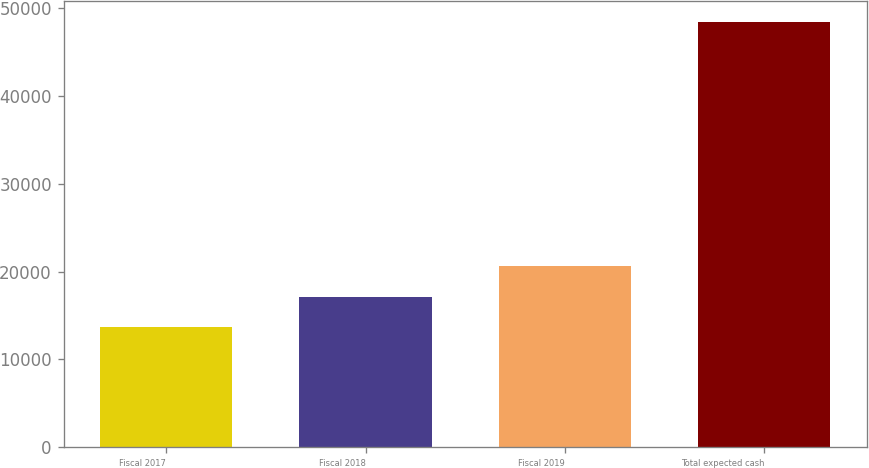<chart> <loc_0><loc_0><loc_500><loc_500><bar_chart><fcel>Fiscal 2017<fcel>Fiscal 2018<fcel>Fiscal 2019<fcel>Total expected cash<nl><fcel>13679<fcel>17155.9<fcel>20632.8<fcel>48448<nl></chart> 